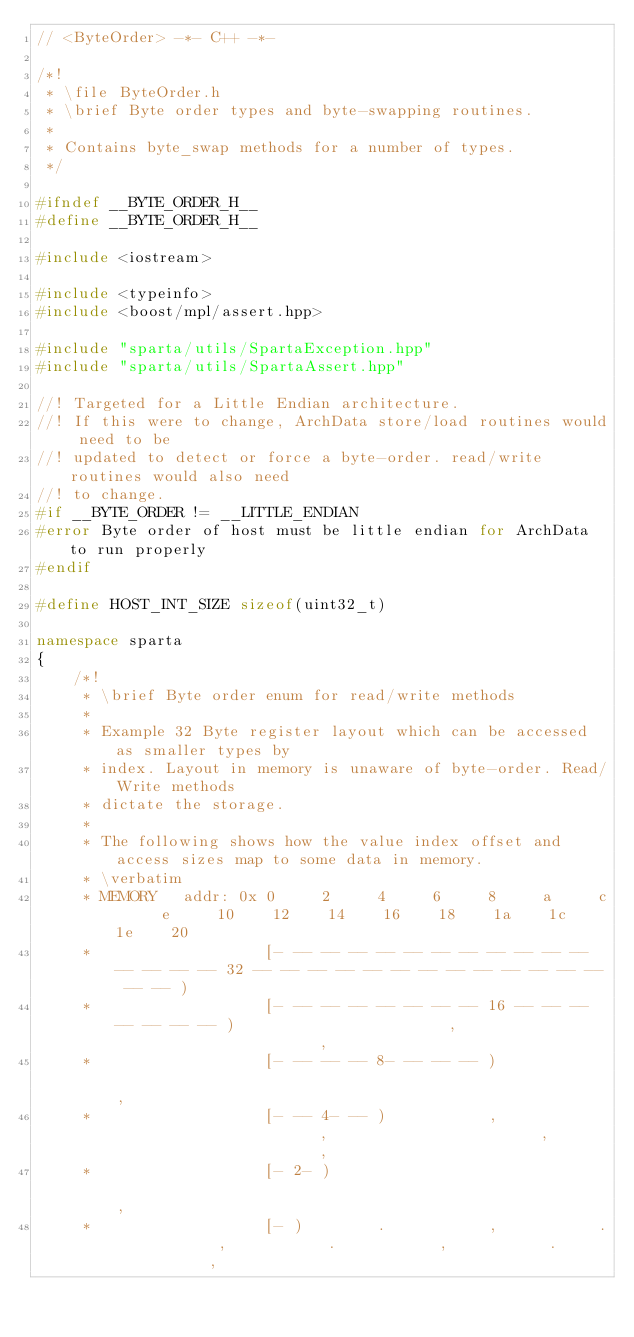Convert code to text. <code><loc_0><loc_0><loc_500><loc_500><_C++_>// <ByteOrder> -*- C++ -*-

/*!
 * \file ByteOrder.h
 * \brief Byte order types and byte-swapping routines.
 *
 * Contains byte_swap methods for a number of types.
 */

#ifndef __BYTE_ORDER_H__
#define __BYTE_ORDER_H__

#include <iostream>

#include <typeinfo>
#include <boost/mpl/assert.hpp>

#include "sparta/utils/SpartaException.hpp"
#include "sparta/utils/SpartaAssert.hpp"

//! Targeted for a Little Endian architecture.
//! If this were to change, ArchData store/load routines would need to be
//! updated to detect or force a byte-order. read/write routines would also need
//! to change.
#if __BYTE_ORDER != __LITTLE_ENDIAN
#error Byte order of host must be little endian for ArchData to run properly
#endif

#define HOST_INT_SIZE sizeof(uint32_t)

namespace sparta
{
    /*!
     * \brief Byte order enum for read/write methods
     *
     * Example 32 Byte register layout which can be accessed as smaller types by
     * index. Layout in memory is unaware of byte-order. Read/Write methods
     * dictate the storage.
     *
     * The following shows how the value index offset and access sizes map to some data in memory.
     * \verbatim
     * MEMORY   addr: 0x 0     2     4     6     8     a     c     e     10    12    14    16    18    1a    1c    1e    20
     *                   [- -- -- -- -- -- -- -- -- -- -- -- -- -- -- -- 32 -- -- -- -- -- -- -- -- -- -- -- -- -- -- -- )
     *                   [- -- -- -- -- -- -- -- 16 -- -- -- -- -- -- -- )                       ,                       ,
     *                   [- -- -- -- 8- -- -- -- )                                                                       ,
     *                   [- -- 4- -- )           ,                       ,                       ,                       ,
     *                   [- 2- )                                                                                         ,
     *                   [- )        .           ,           .           ,           .           ,           .           ,</code> 